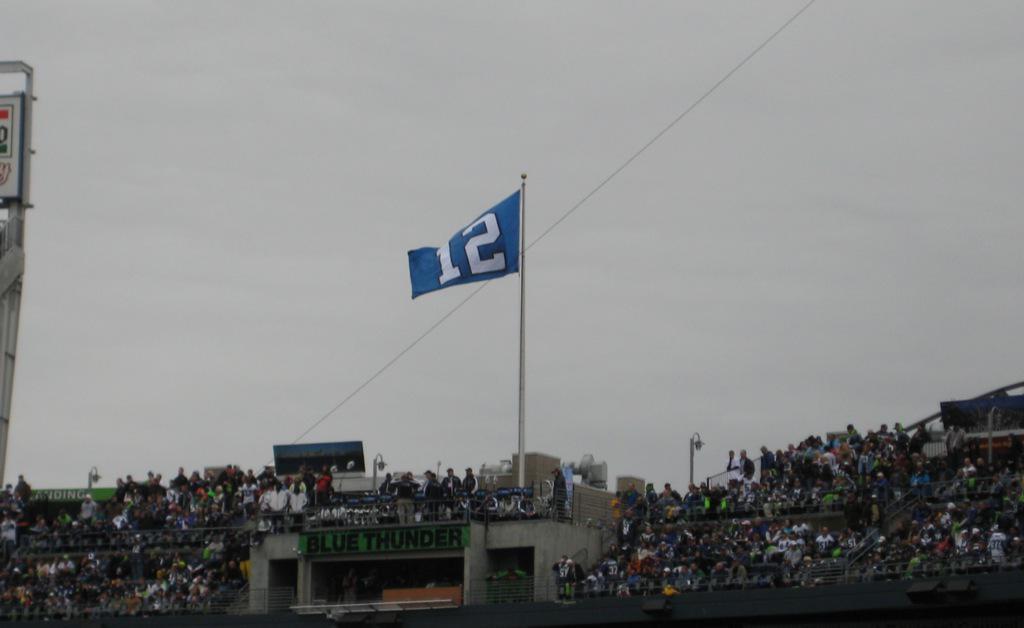What number is on the flag?
Offer a terse response. 12. What is on the green banner?
Offer a terse response. Blue thunder. 